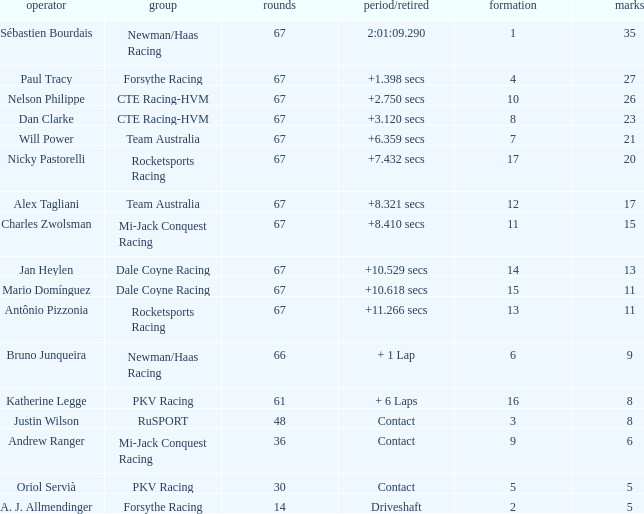How many average laps for Alex Tagliani with more than 17 points? None. 